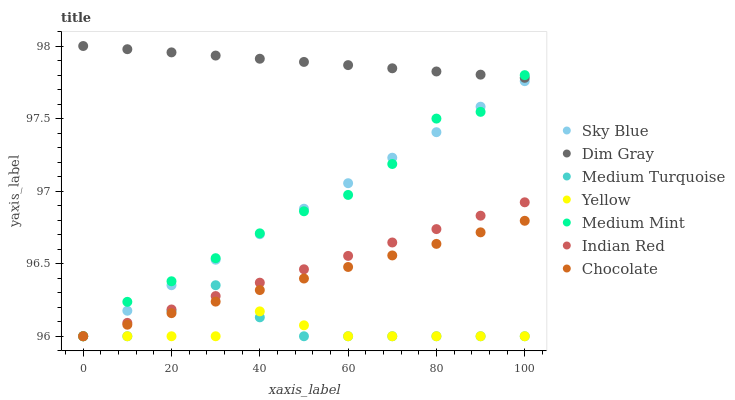Does Yellow have the minimum area under the curve?
Answer yes or no. Yes. Does Dim Gray have the maximum area under the curve?
Answer yes or no. Yes. Does Medium Turquoise have the minimum area under the curve?
Answer yes or no. No. Does Medium Turquoise have the maximum area under the curve?
Answer yes or no. No. Is Chocolate the smoothest?
Answer yes or no. Yes. Is Medium Mint the roughest?
Answer yes or no. Yes. Is Dim Gray the smoothest?
Answer yes or no. No. Is Dim Gray the roughest?
Answer yes or no. No. Does Medium Mint have the lowest value?
Answer yes or no. Yes. Does Dim Gray have the lowest value?
Answer yes or no. No. Does Dim Gray have the highest value?
Answer yes or no. Yes. Does Medium Turquoise have the highest value?
Answer yes or no. No. Is Sky Blue less than Dim Gray?
Answer yes or no. Yes. Is Dim Gray greater than Medium Turquoise?
Answer yes or no. Yes. Does Medium Turquoise intersect Medium Mint?
Answer yes or no. Yes. Is Medium Turquoise less than Medium Mint?
Answer yes or no. No. Is Medium Turquoise greater than Medium Mint?
Answer yes or no. No. Does Sky Blue intersect Dim Gray?
Answer yes or no. No. 